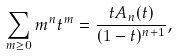<formula> <loc_0><loc_0><loc_500><loc_500>\sum _ { m \geq 0 } m ^ { n } t ^ { m } = \frac { t A _ { n } ( t ) } { ( 1 - t ) ^ { n + 1 } } ,</formula> 